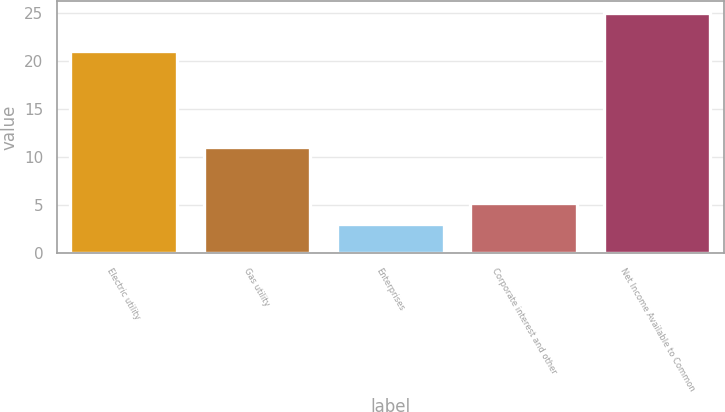Convert chart to OTSL. <chart><loc_0><loc_0><loc_500><loc_500><bar_chart><fcel>Electric utility<fcel>Gas utility<fcel>Enterprises<fcel>Corporate interest and other<fcel>Net Income Available to Common<nl><fcel>21<fcel>11<fcel>3<fcel>5.2<fcel>25<nl></chart> 